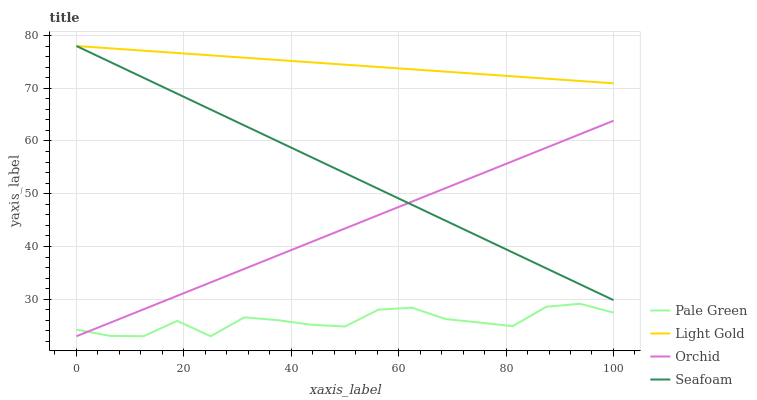Does Pale Green have the minimum area under the curve?
Answer yes or no. Yes. Does Light Gold have the maximum area under the curve?
Answer yes or no. Yes. Does Seafoam have the minimum area under the curve?
Answer yes or no. No. Does Seafoam have the maximum area under the curve?
Answer yes or no. No. Is Orchid the smoothest?
Answer yes or no. Yes. Is Pale Green the roughest?
Answer yes or no. Yes. Is Light Gold the smoothest?
Answer yes or no. No. Is Light Gold the roughest?
Answer yes or no. No. Does Pale Green have the lowest value?
Answer yes or no. Yes. Does Seafoam have the lowest value?
Answer yes or no. No. Does Seafoam have the highest value?
Answer yes or no. Yes. Does Orchid have the highest value?
Answer yes or no. No. Is Pale Green less than Light Gold?
Answer yes or no. Yes. Is Light Gold greater than Pale Green?
Answer yes or no. Yes. Does Seafoam intersect Orchid?
Answer yes or no. Yes. Is Seafoam less than Orchid?
Answer yes or no. No. Is Seafoam greater than Orchid?
Answer yes or no. No. Does Pale Green intersect Light Gold?
Answer yes or no. No. 